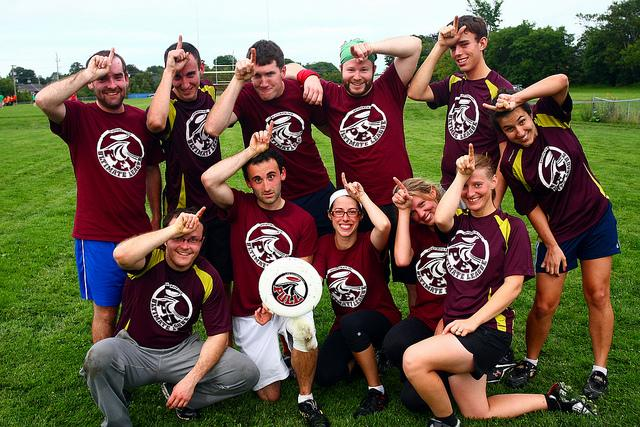What is the finger everyone is holding up commonly called? index finger 